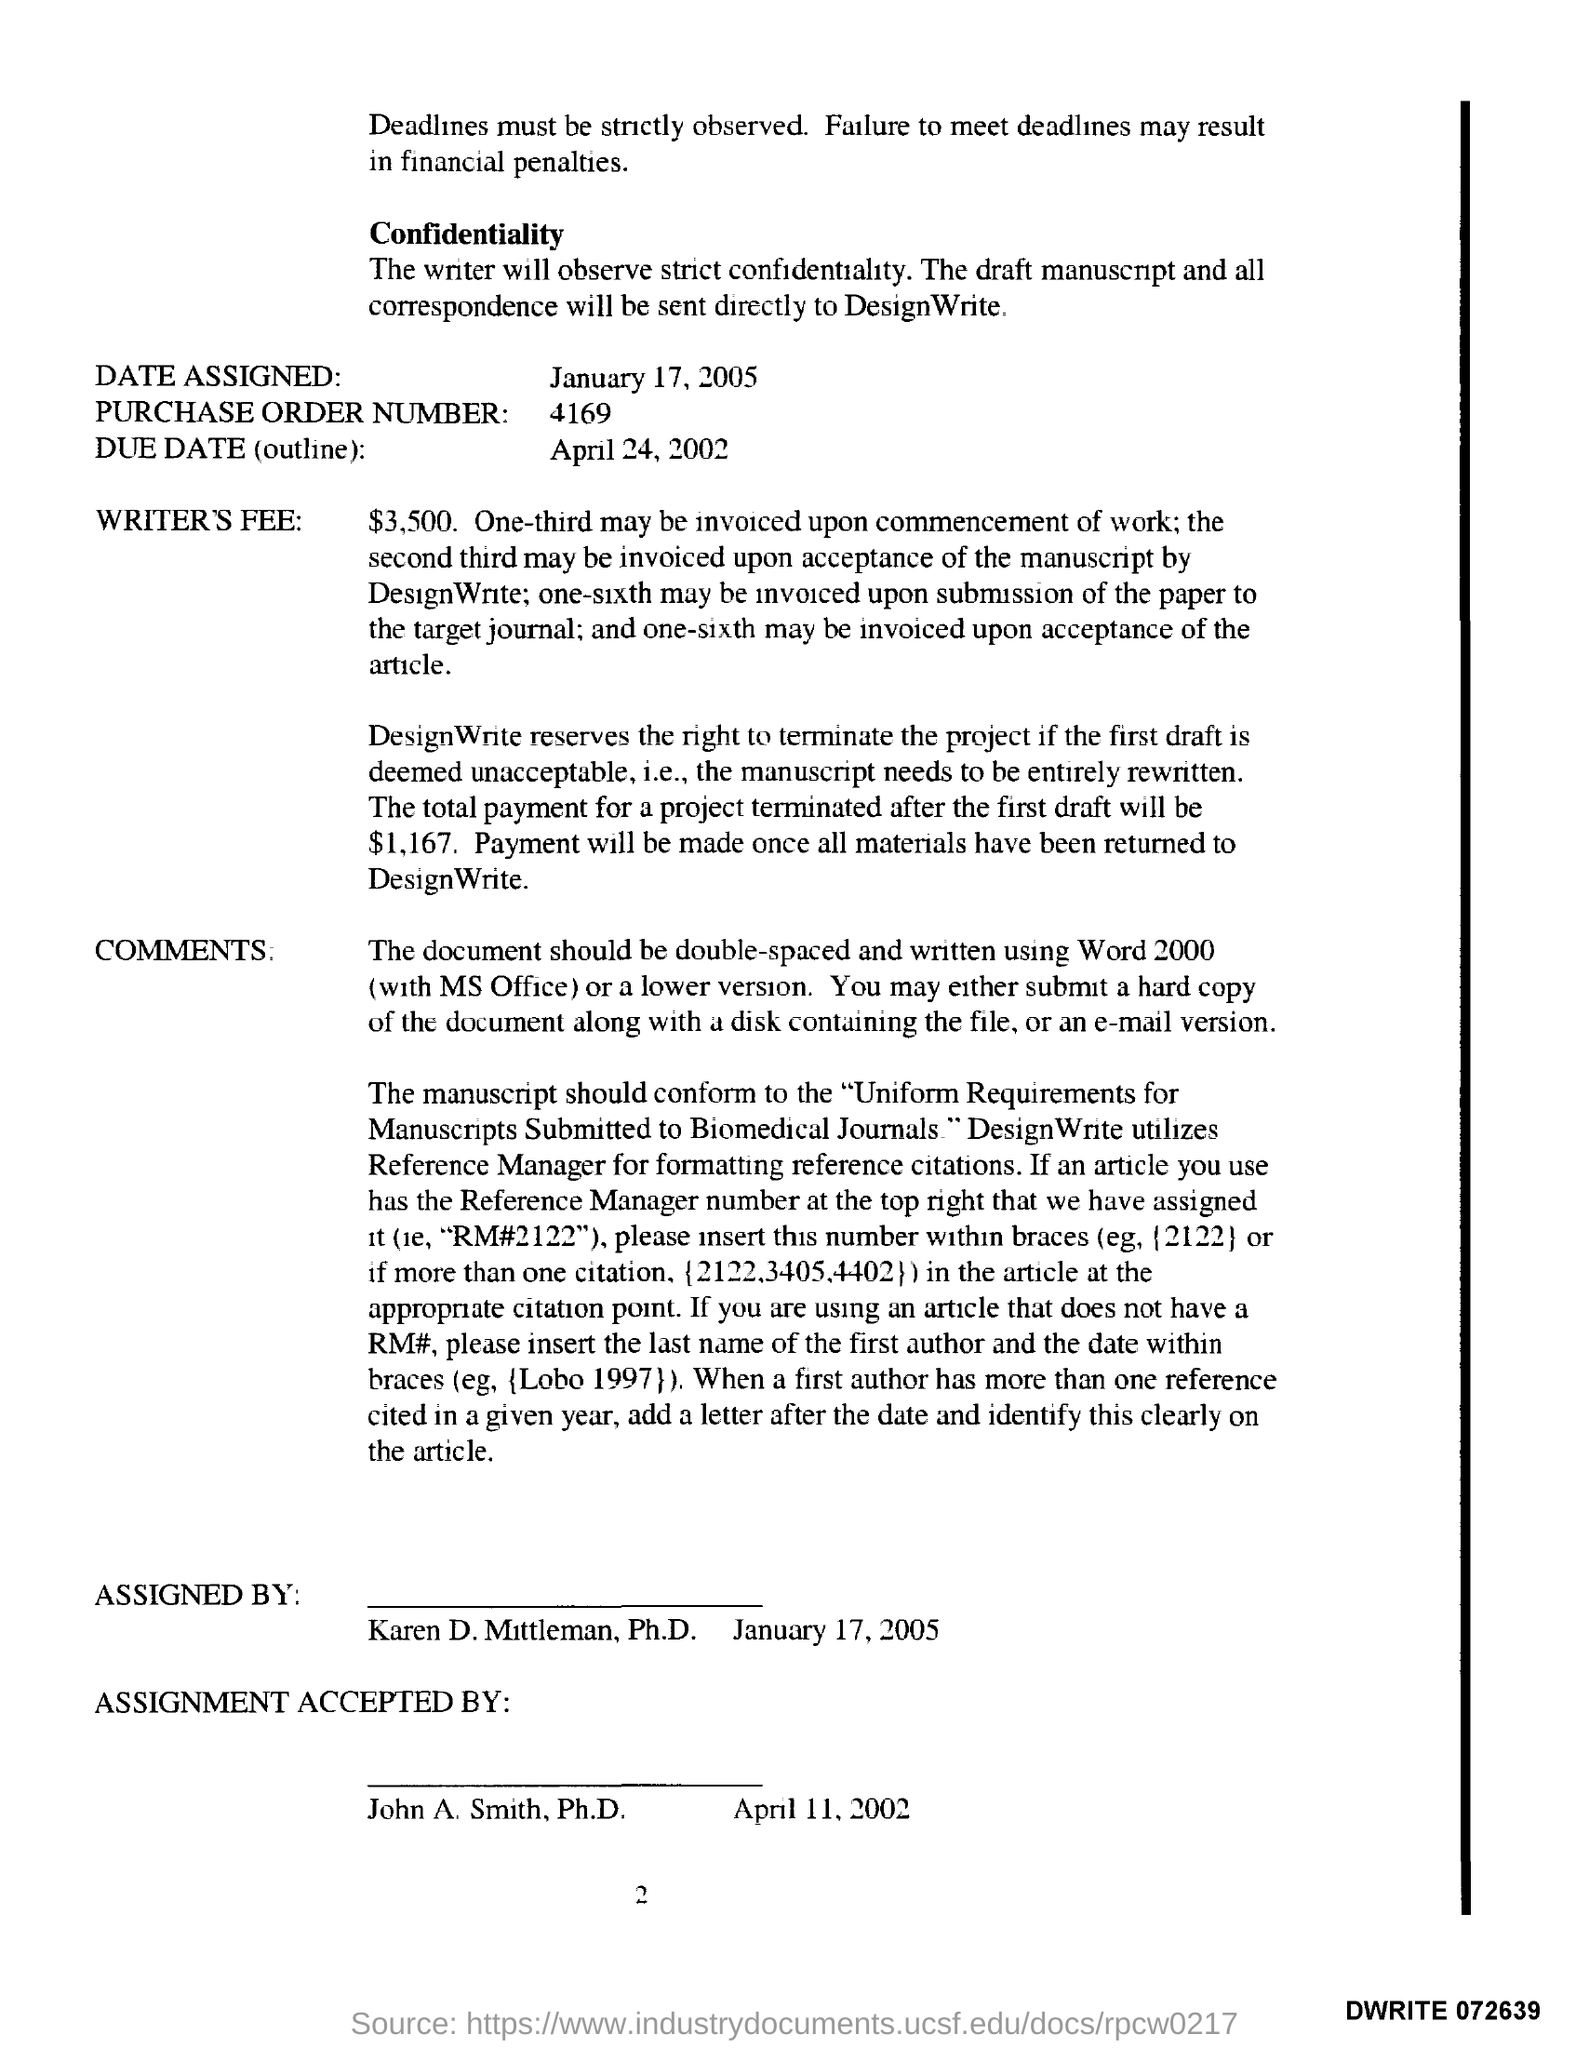List a handful of essential elements in this visual. The purchase order number is 4169. The date assigned is January 17, 2005. The due date for the outline is April 24, 2002. 